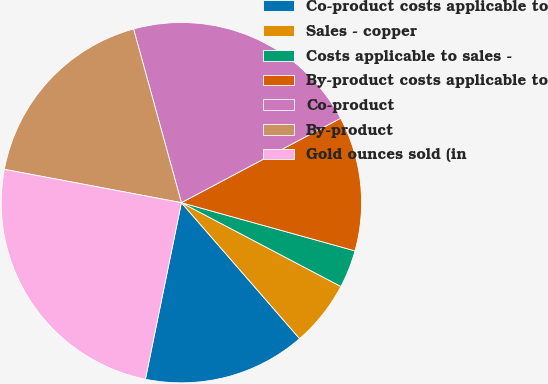Convert chart to OTSL. <chart><loc_0><loc_0><loc_500><loc_500><pie_chart><fcel>Co-product costs applicable to<fcel>Sales - copper<fcel>Costs applicable to sales -<fcel>By-product costs applicable to<fcel>Co-product<fcel>By-product<fcel>Gold ounces sold (in<nl><fcel>14.59%<fcel>5.91%<fcel>3.39%<fcel>12.07%<fcel>21.52%<fcel>17.76%<fcel>24.76%<nl></chart> 